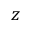Convert formula to latex. <formula><loc_0><loc_0><loc_500><loc_500>z</formula> 